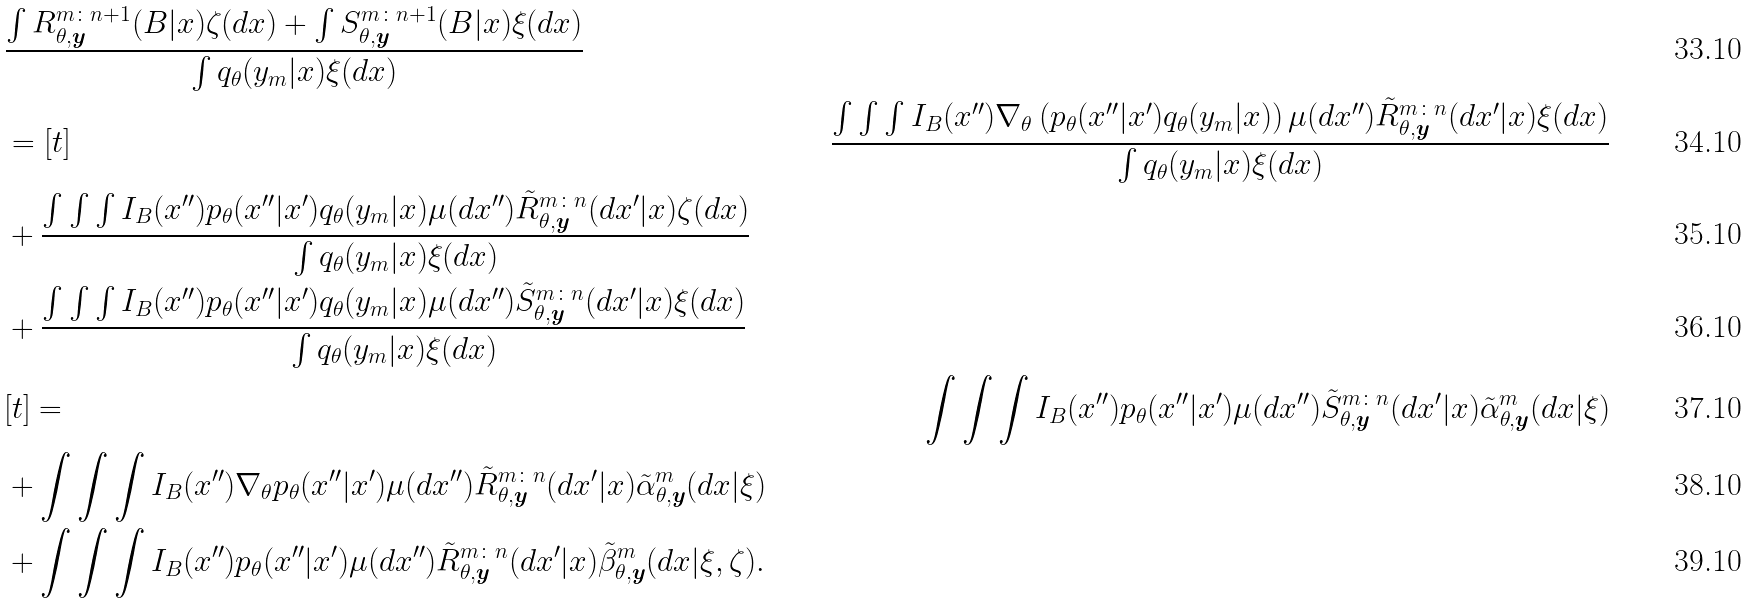Convert formula to latex. <formula><loc_0><loc_0><loc_500><loc_500>& \frac { \int R _ { \theta , \boldsymbol y } ^ { m \colon n + 1 } ( B | x ) \zeta ( d x ) + \int S _ { \theta , \boldsymbol y } ^ { m \colon n + 1 } ( B | x ) \xi ( d x ) } { \int q _ { \theta } ( y _ { m } | x ) \xi ( d x ) } \\ & = [ t ] & \frac { \int \int \int I _ { B } ( x ^ { \prime \prime } ) \nabla _ { \theta } \left ( p _ { \theta } ( x ^ { \prime \prime } | x ^ { \prime } ) q _ { \theta } ( y _ { m } | x ) \right ) \mu ( d x ^ { \prime \prime } ) \tilde { R } _ { \theta , \boldsymbol y } ^ { m \colon n } ( d x ^ { \prime } | x ) \xi ( d x ) } { \int q _ { \theta } ( y _ { m } | x ) \xi ( d x ) } \\ & + \frac { \int \int \int I _ { B } ( x ^ { \prime \prime } ) p _ { \theta } ( x ^ { \prime \prime } | x ^ { \prime } ) q _ { \theta } ( y _ { m } | x ) \mu ( d x ^ { \prime \prime } ) \tilde { R } _ { \theta , \boldsymbol y } ^ { m \colon n } ( d x ^ { \prime } | x ) \zeta ( d x ) } { \int q _ { \theta } ( y _ { m } | x ) \xi ( d x ) } \\ & + \frac { \int \int \int I _ { B } ( x ^ { \prime \prime } ) p _ { \theta } ( x ^ { \prime \prime } | x ^ { \prime } ) q _ { \theta } ( y _ { m } | x ) \mu ( d x ^ { \prime \prime } ) \tilde { S } _ { \theta , \boldsymbol y } ^ { m \colon n } ( d x ^ { \prime } | x ) \xi ( d x ) } { \int q _ { \theta } ( y _ { m } | x ) \xi ( d x ) } \\ & [ t ] = & \int \int \int I _ { B } ( x ^ { \prime \prime } ) p _ { \theta } ( x ^ { \prime \prime } | x ^ { \prime } ) \mu ( d x ^ { \prime \prime } ) \tilde { S } _ { \theta , \boldsymbol y } ^ { m \colon n } ( d x ^ { \prime } | x ) \tilde { \alpha } _ { \theta , \boldsymbol y } ^ { m } ( d x | \xi ) \\ & + \int \int \int I _ { B } ( x ^ { \prime \prime } ) \nabla _ { \theta } p _ { \theta } ( x ^ { \prime \prime } | x ^ { \prime } ) \mu ( d x ^ { \prime \prime } ) \tilde { R } _ { \theta , \boldsymbol y } ^ { m \colon n } ( d x ^ { \prime } | x ) \tilde { \alpha } _ { \theta , \boldsymbol y } ^ { m } ( d x | \xi ) \\ & + \int \int \int I _ { B } ( x ^ { \prime \prime } ) p _ { \theta } ( x ^ { \prime \prime } | x ^ { \prime } ) \mu ( d x ^ { \prime \prime } ) \tilde { R } _ { \theta , \boldsymbol y } ^ { m \colon n } ( d x ^ { \prime } | x ) \tilde { \beta } _ { \theta , \boldsymbol y } ^ { m } ( d x | \xi , \zeta ) .</formula> 